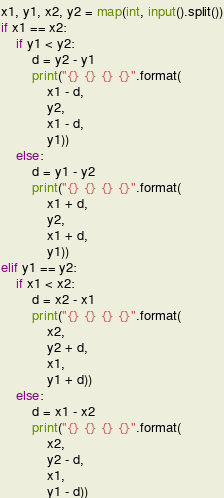<code> <loc_0><loc_0><loc_500><loc_500><_Python_>x1, y1, x2, y2 = map(int, input().split())
if x1 == x2:
    if y1 < y2:
        d = y2 - y1
        print("{} {} {} {}".format(
            x1 - d,
            y2,
            x1 - d,
            y1))
    else:
        d = y1 - y2
        print("{} {} {} {}".format(
            x1 + d,
            y2,
            x1 + d,
            y1))
elif y1 == y2:
    if x1 < x2:
        d = x2 - x1
        print("{} {} {} {}".format(
            x2,
            y2 + d,
            x1,
            y1 + d))
    else:
        d = x1 - x2
        print("{} {} {} {}".format(
            x2,
            y2 - d,
            x1,
            y1 - d))
</code> 